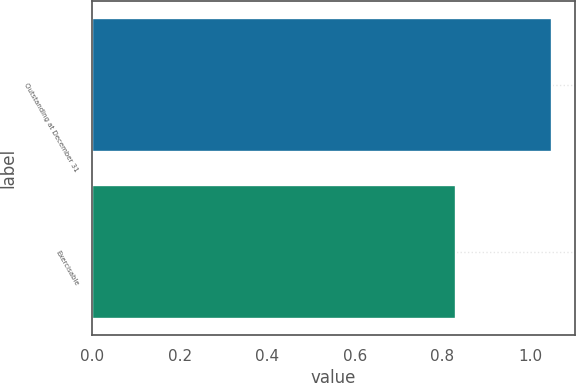Convert chart. <chart><loc_0><loc_0><loc_500><loc_500><bar_chart><fcel>Outstanding at December 31<fcel>Exercisable<nl><fcel>1.05<fcel>0.83<nl></chart> 